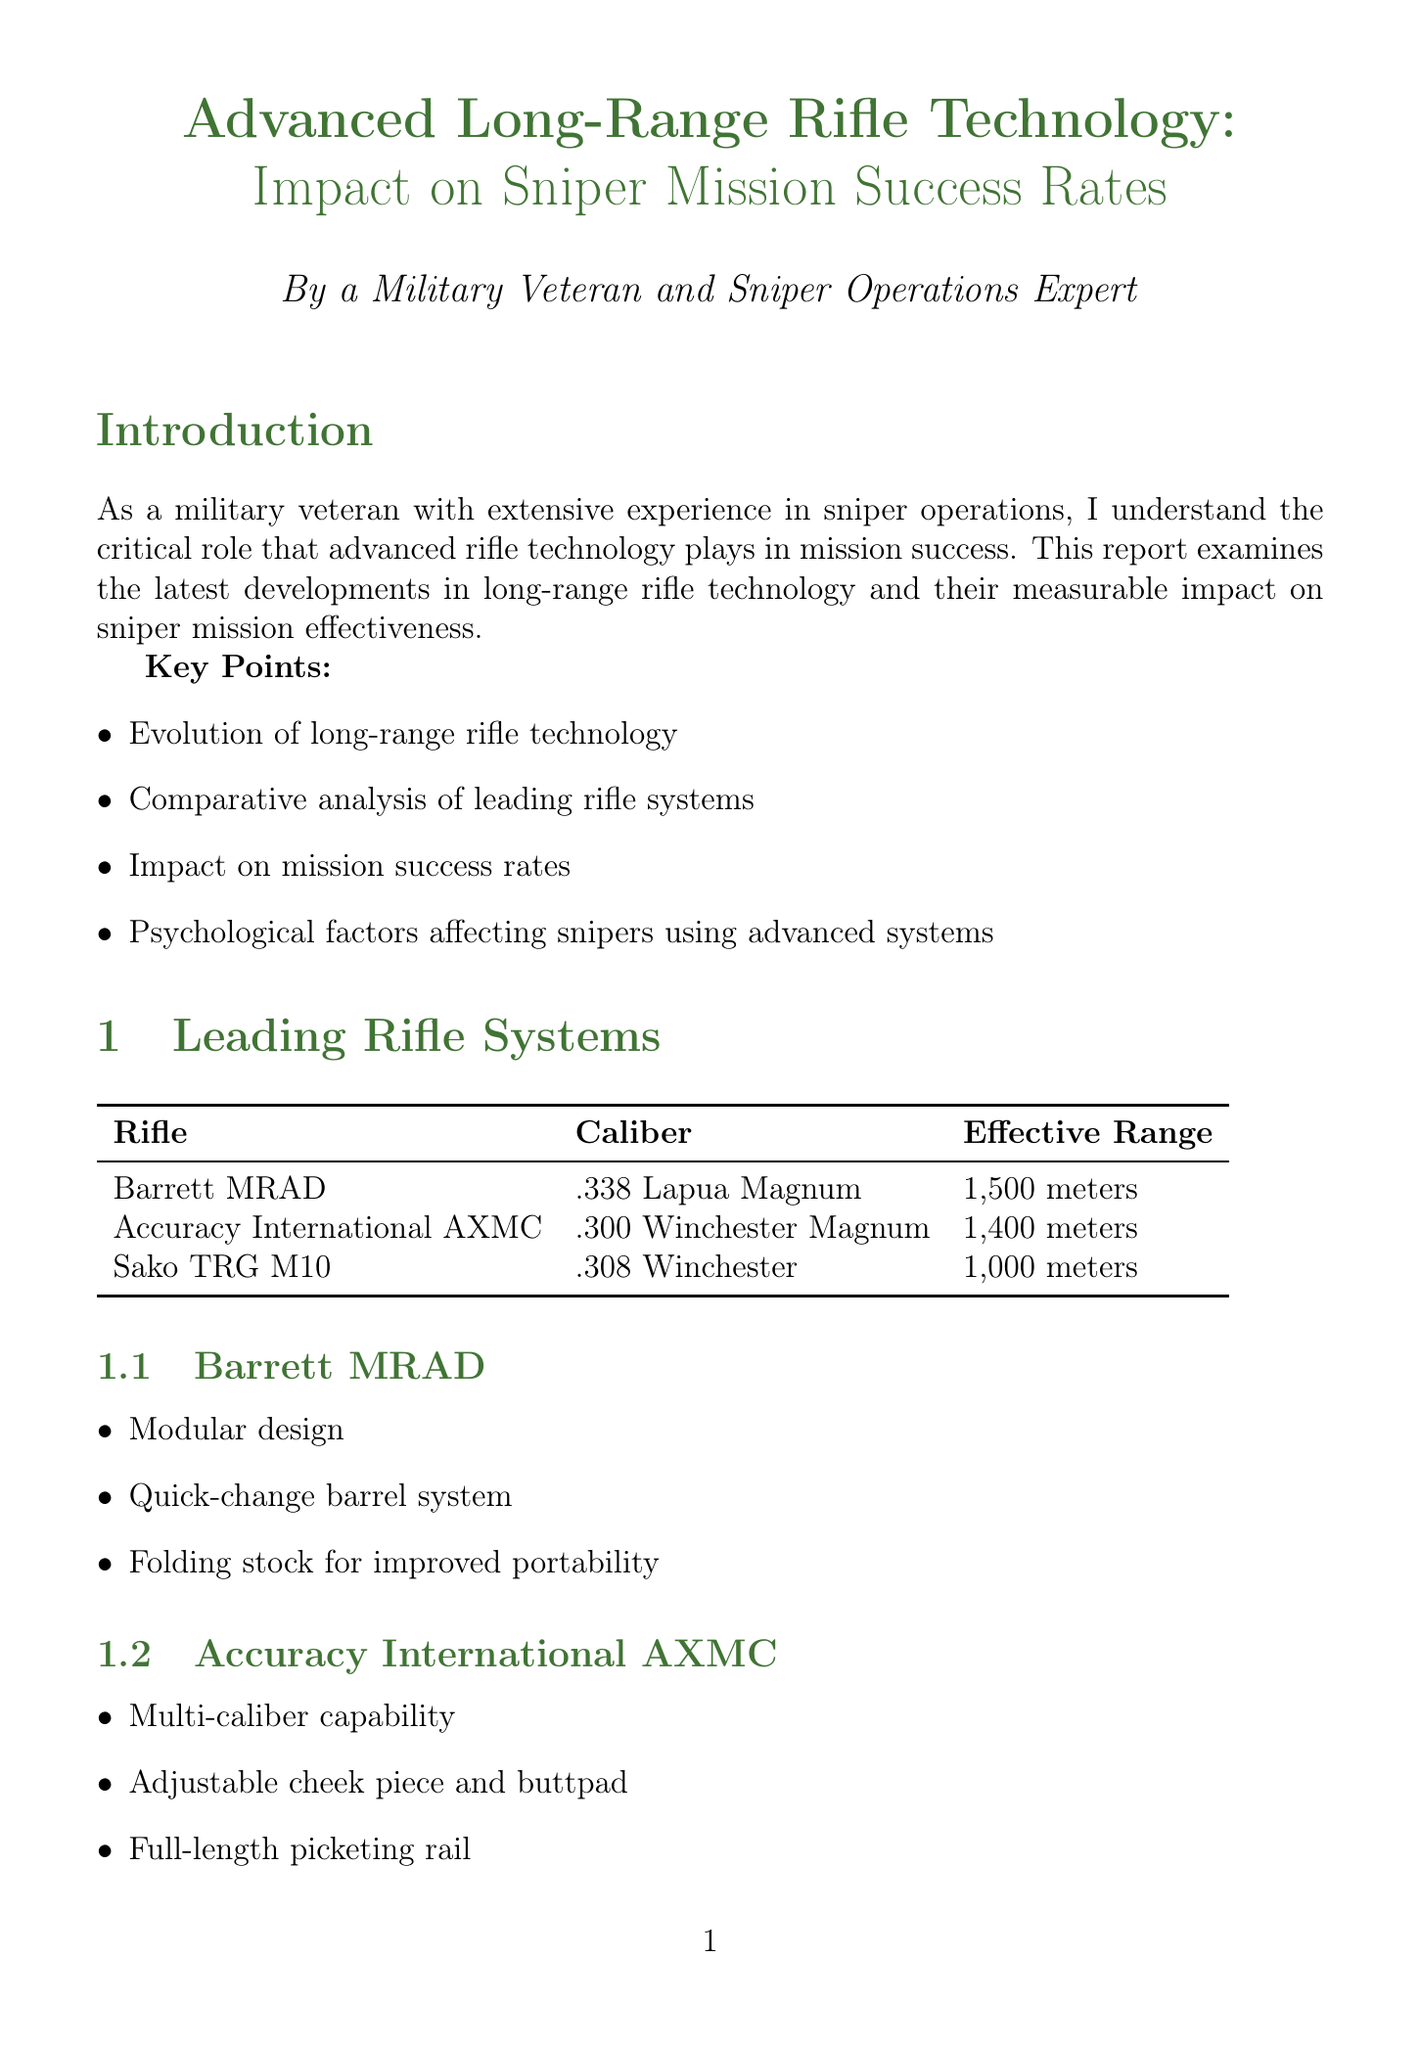what is the title of the report? The title of the report is provided at the beginning of the document and is "Advanced Long-Range Rifle Technology: Impact on Sniper Mission Success Rates."
Answer: Advanced Long-Range Rifle Technology: Impact on Sniper Mission Success Rates what caliber is the Barrett MRAD? The document lists the caliber of the Barrett MRAD under the rifle systems section.
Answer: .338 Lapua Magnum what is the effective range of the Accuracy International AXMC? The effective range of the Accuracy International AXMC is specified in the rifle systems table.
Answer: 1,400 meters how much has the success rate improved from 2015 to 2021? The improvement in success rate is detailed in the impact on mission success section, indicating a specific increase from 72% in 2015 to 92% in 2021.
Answer: 20% which psychological factor has been identified as a potential challenge? The document lists challenges in the psychological considerations section, identifying multiple aspects, including one particular factor.
Answer: Overreliance on technology what type of materials innovation is mentioned in the report? The materials section of technological advancements details innovations; one specific type is sought.
Answer: Carbon fiber reinforced polymer stocks which year has the highest recorded success rate? The years and their respective success rates are shown in the mission success rate improvement chart, making it clear which year had the highest success.
Answer: 2021 what is a key feature of the Sako TRG M10? The key features of the Sako TRG M10 are listed under the rifle systems, allowing us to identify one.
Answer: Interchangeable barrels and bolt faces 